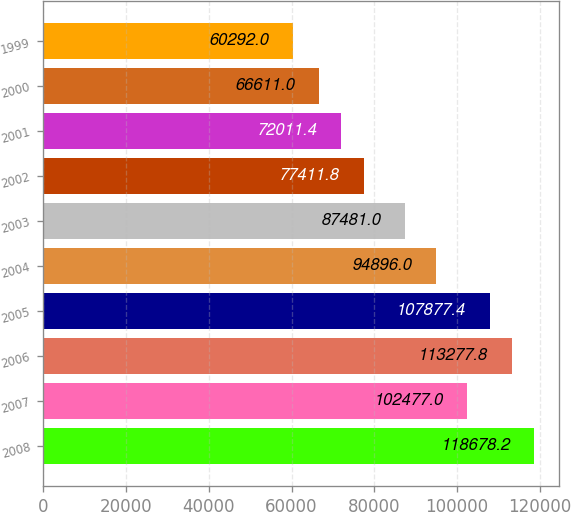Convert chart. <chart><loc_0><loc_0><loc_500><loc_500><bar_chart><fcel>2008<fcel>2007<fcel>2006<fcel>2005<fcel>2004<fcel>2003<fcel>2002<fcel>2001<fcel>2000<fcel>1999<nl><fcel>118678<fcel>102477<fcel>113278<fcel>107877<fcel>94896<fcel>87481<fcel>77411.8<fcel>72011.4<fcel>66611<fcel>60292<nl></chart> 